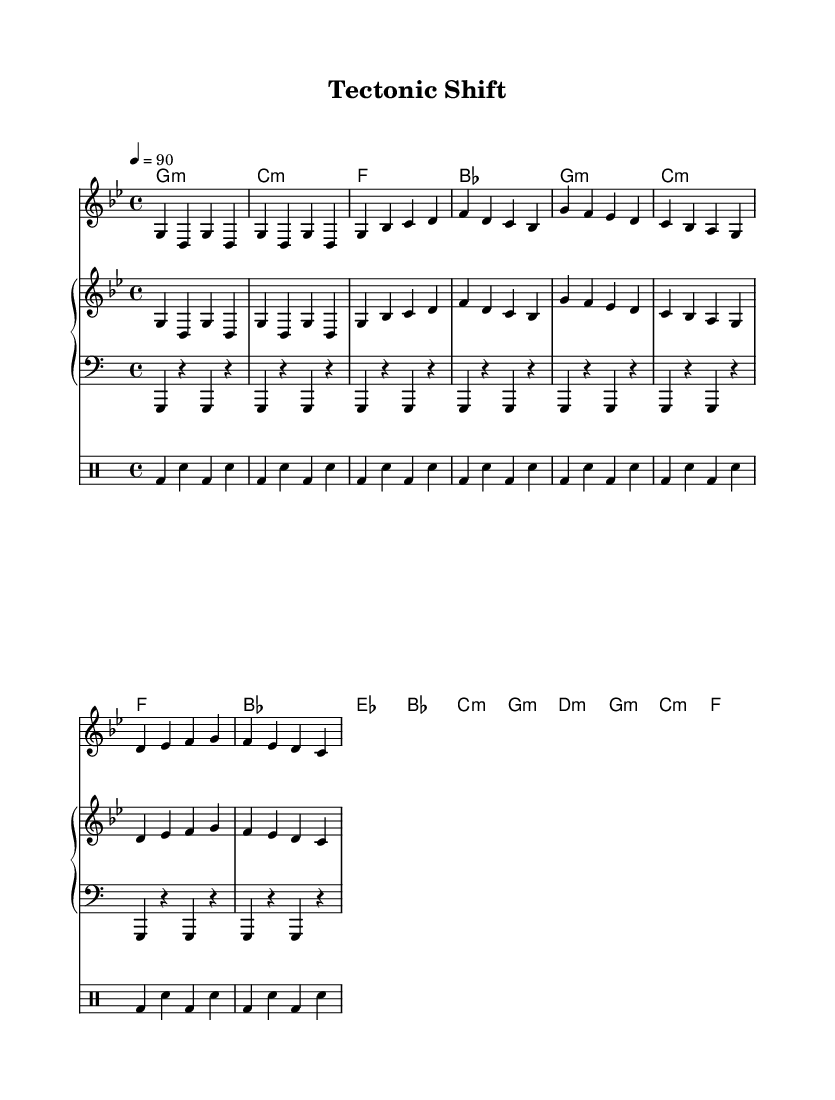What is the key signature of this music? The key signature is G minor, which has two flats (B flat and E flat) indicated at the beginning of the staff.
Answer: G minor What is the time signature of the music? The time signature is indicated at the beginning of the sheet music as 4/4, meaning there are four beats in each measure and a quarter note receives one beat.
Answer: 4/4 What is the tempo marking of the piece? The tempo marking is indicated as "4 = 90," which means the quarter note should be played at a speed of 90 beats per minute.
Answer: 90 How many measures are in the intro section? The intro section consists of 4 measures, as indicated by the repeated sequence of notes in that part of the music.
Answer: 4 What is the first chord of the verse? The first chord of the verse is G minor, as seen in the harmonies section under the verse section of the sheet music.
Answer: G minor What is the structure of the music by sections? The structure can be identified as Intro, Verse, Chorus, and Bridge, as labeled in the layout of the sheet music.
Answer: Intro, Verse, Chorus, Bridge What is the main theme addressed in the rap? The main theme addresses environmental issues and natural disasters, which aligns with the conscious rap genre reflecting on social and ecological topics.
Answer: Environmental issues 